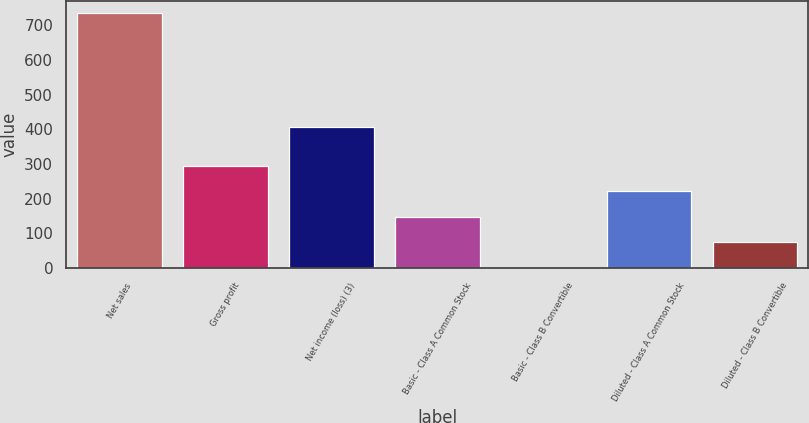Convert chart. <chart><loc_0><loc_0><loc_500><loc_500><bar_chart><fcel>Net sales<fcel>Gross profit<fcel>Net income (loss) (3)<fcel>Basic - Class A Common Stock<fcel>Basic - Class B Convertible<fcel>Diluted - Class A Common Stock<fcel>Diluted - Class B Convertible<nl><fcel>735.1<fcel>295.07<fcel>406.8<fcel>148.39<fcel>1.71<fcel>221.73<fcel>75.05<nl></chart> 